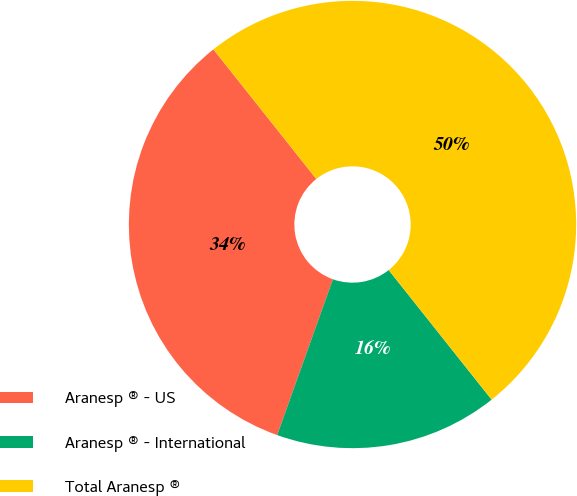Convert chart to OTSL. <chart><loc_0><loc_0><loc_500><loc_500><pie_chart><fcel>Aranesp ® - US<fcel>Aranesp ® - International<fcel>Total Aranesp ®<nl><fcel>33.85%<fcel>16.15%<fcel>50.0%<nl></chart> 